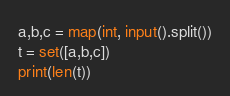<code> <loc_0><loc_0><loc_500><loc_500><_Python_>a,b,c = map(int, input().split())
t = set([a,b,c])
print(len(t))</code> 